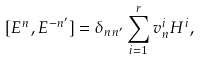Convert formula to latex. <formula><loc_0><loc_0><loc_500><loc_500>[ E ^ { n } , E ^ { - n ^ { \prime } } ] = \delta _ { n n ^ { \prime } } \sum _ { i = 1 } ^ { r } v _ { n } ^ { i } H ^ { i } ,</formula> 